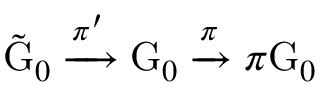<formula> <loc_0><loc_0><loc_500><loc_500>\tilde { G } _ { 0 } \xrightarrow { \pi ^ { \prime } } G _ { 0 } \xrightarrow { \pi } \pi G _ { 0 }</formula> 